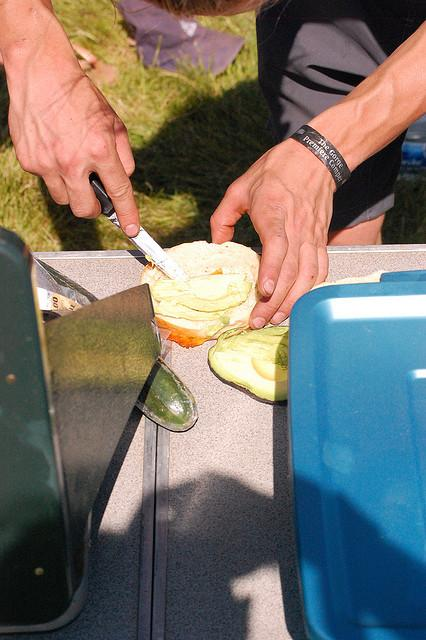At what type event is the man preparing food? picnic 